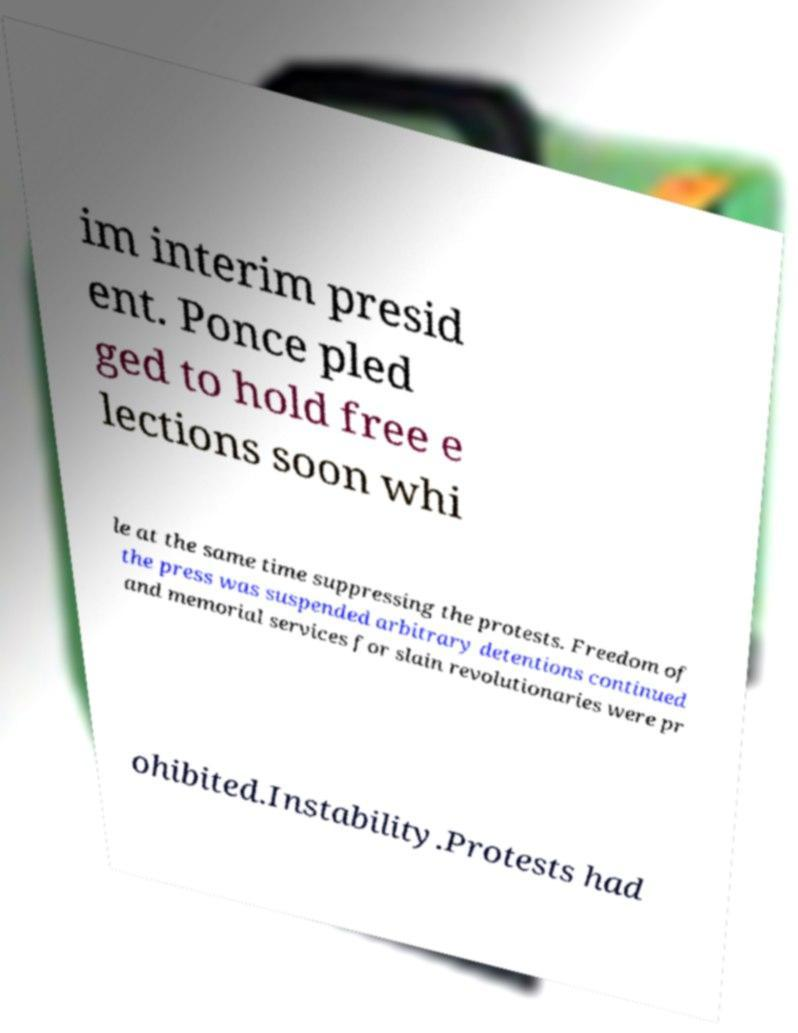There's text embedded in this image that I need extracted. Can you transcribe it verbatim? im interim presid ent. Ponce pled ged to hold free e lections soon whi le at the same time suppressing the protests. Freedom of the press was suspended arbitrary detentions continued and memorial services for slain revolutionaries were pr ohibited.Instability.Protests had 